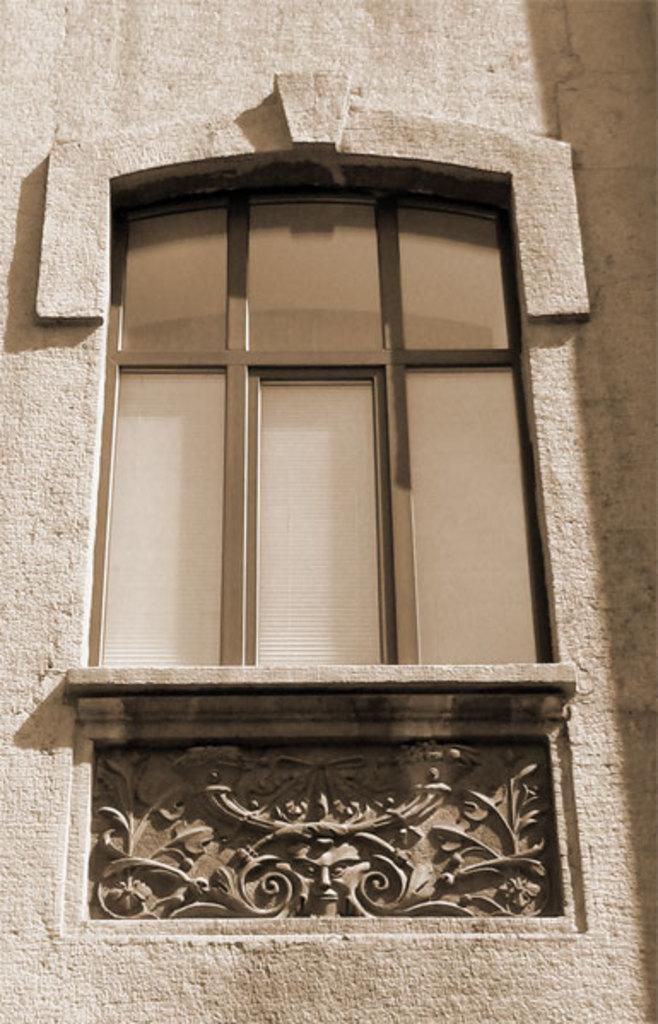How would you summarize this image in a sentence or two? There is a zoom in picture of a window of a building as we can see in the middle of this image. 